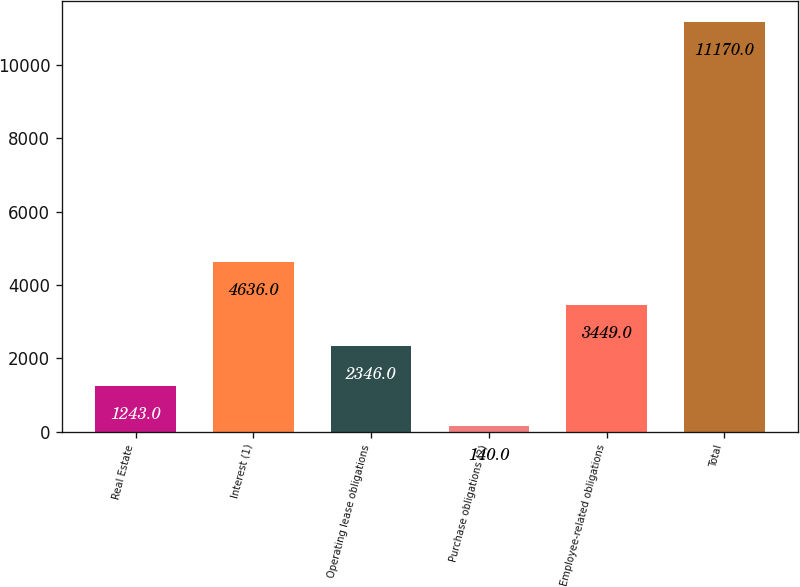Convert chart to OTSL. <chart><loc_0><loc_0><loc_500><loc_500><bar_chart><fcel>Real Estate<fcel>Interest (1)<fcel>Operating lease obligations<fcel>Purchase obligations (2)<fcel>Employee-related obligations<fcel>Total<nl><fcel>1243<fcel>4636<fcel>2346<fcel>140<fcel>3449<fcel>11170<nl></chart> 